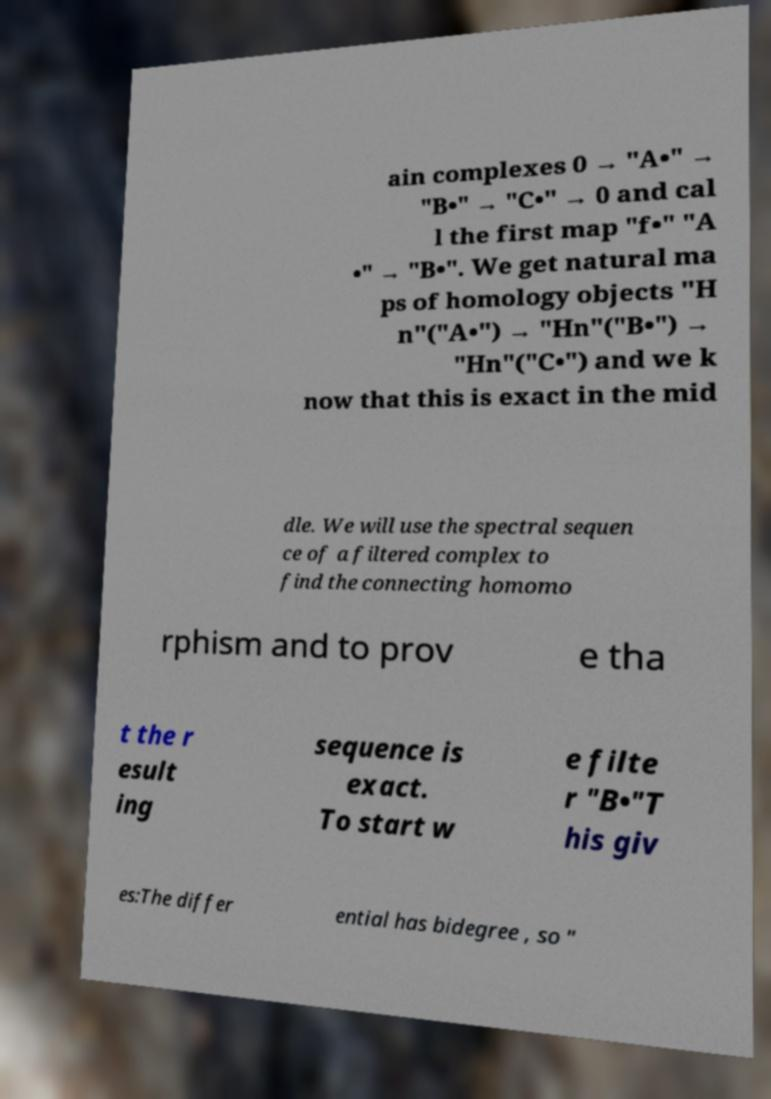Please read and relay the text visible in this image. What does it say? ain complexes 0 → "A•" → "B•" → "C•" → 0 and cal l the first map "f•" "A •" → "B•". We get natural ma ps of homology objects "H n"("A•") → "Hn"("B•") → "Hn"("C•") and we k now that this is exact in the mid dle. We will use the spectral sequen ce of a filtered complex to find the connecting homomo rphism and to prov e tha t the r esult ing sequence is exact. To start w e filte r "B•"T his giv es:The differ ential has bidegree , so " 